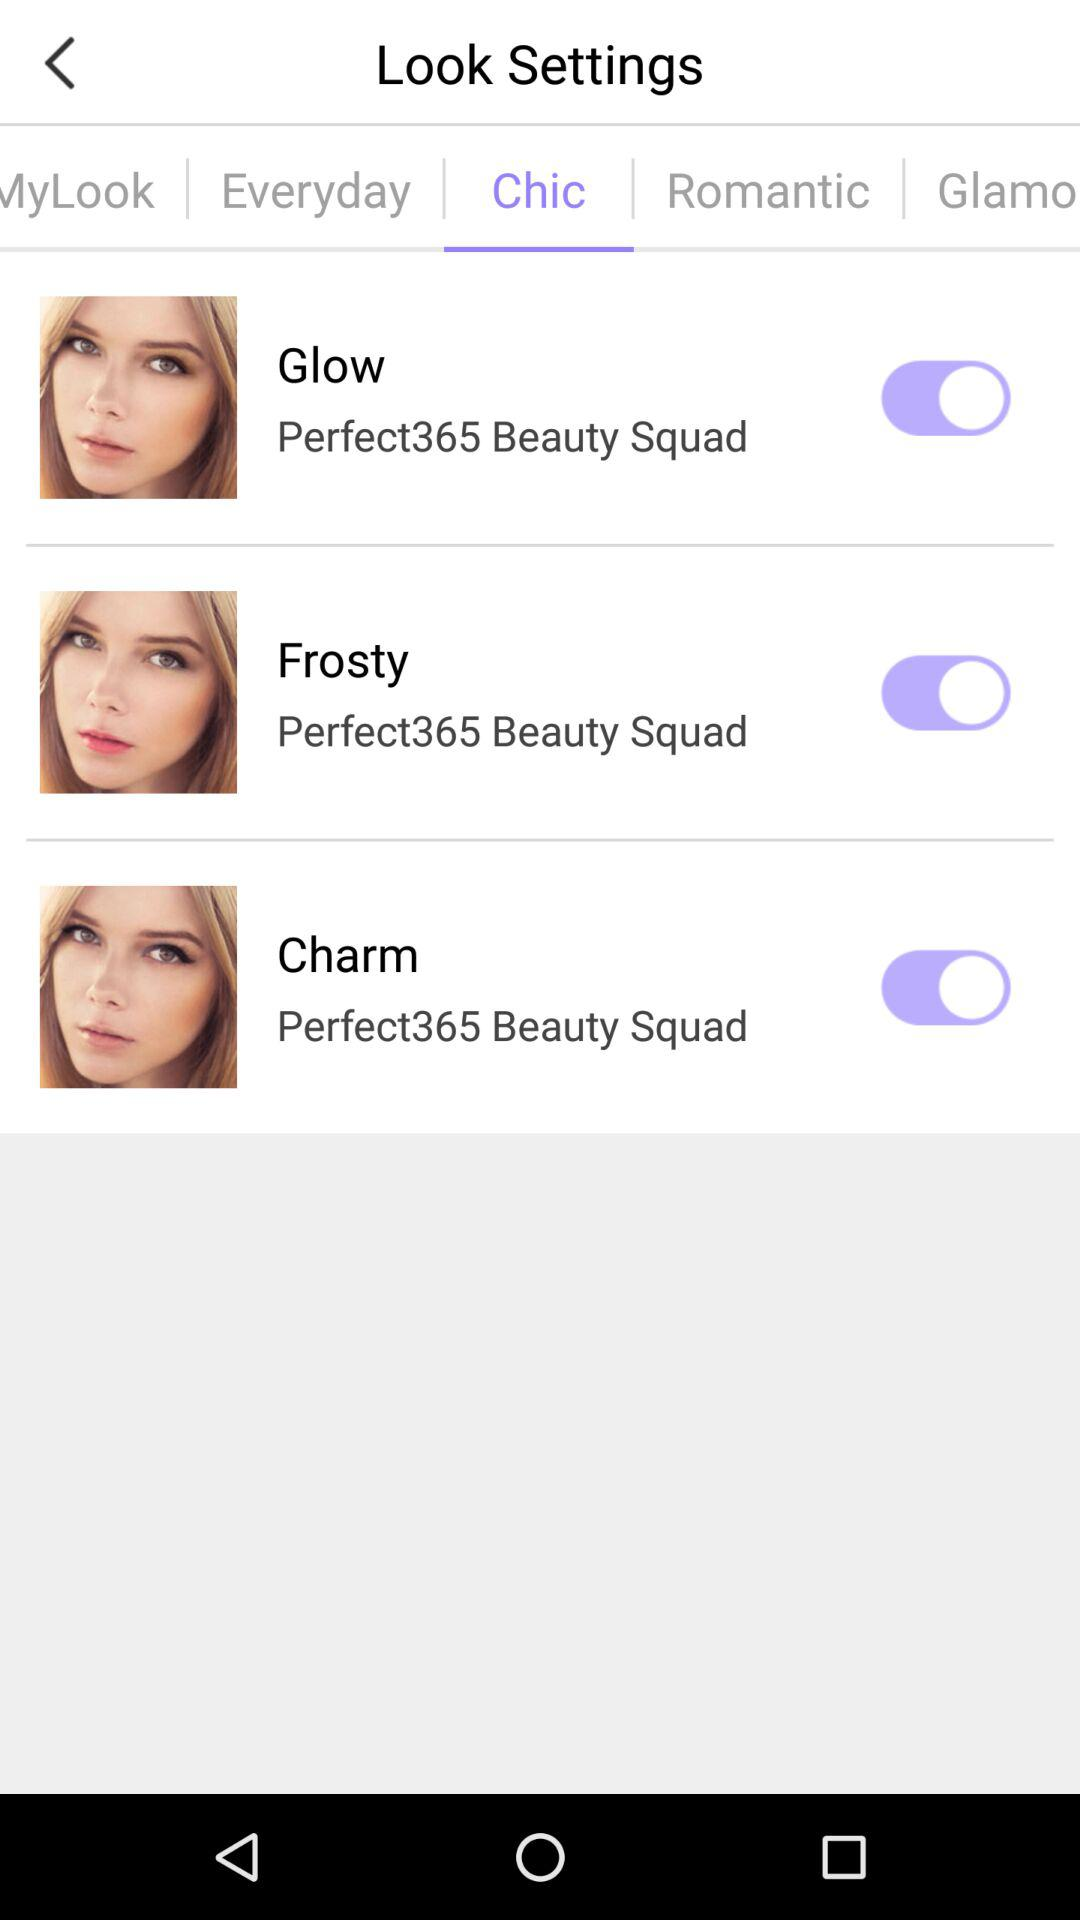What is the status of "Frosty"? The status is "on". 